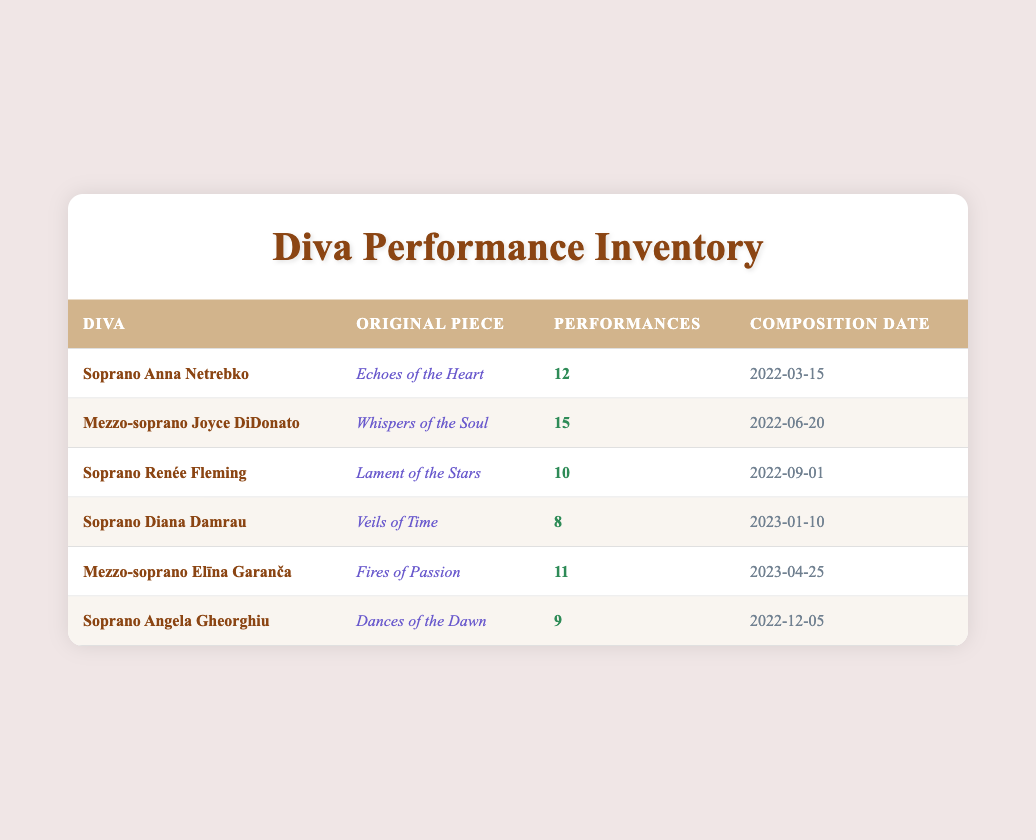What piece did Mezzo-soprano Joyce DiDonato perform? The table indicates that Mezzo-soprano Joyce DiDonato performed "Whispers of the Soul". This is found directly in her row under the 'Original Piece' column.
Answer: Whispers of the Soul Who had the highest number of performances? By examining the 'Performances' column, we see that Mezzo-soprano Joyce DiDonato has the highest number of performances with a total of 15. This can be confirmed by comparing all values in that column.
Answer: 15 How many performances did Soprano Anna Netrebko have compared to Soprano Angela Gheorghiu? Soprano Anna Netrebko had 12 performances, while Soprano Angela Gheorghiu had 9 performances. Subtracting the latter from the former gives us 12 - 9 = 3. This calculation shows that Anna Netrebko performed 3 more times than Angela Gheorghiu.
Answer: 3 Is it true that all the original pieces were composed after 2022? Looking at the 'Composition Date' column, we can see the dates for each piece. The compositions "Echoes of the Heart" (2022-03-15) and "Whispers of the Soul" (2022-06-20) were composed in 2022, while others like "Veils of Time" were composed in 2023, which indicates that not all pieces were composed after 2022. Therefore, the statement is false.
Answer: False What is the average number of performances across all pieces? To find the average number of performances, we need to sum the performances: 12 + 15 + 10 + 8 + 11 + 9 = 65, and then divide that by the number of pieces, which is 6. Thus, the average is 65 / 6 = 10.83. This presents the typical number of performances for the pieces listed.
Answer: 10.83 